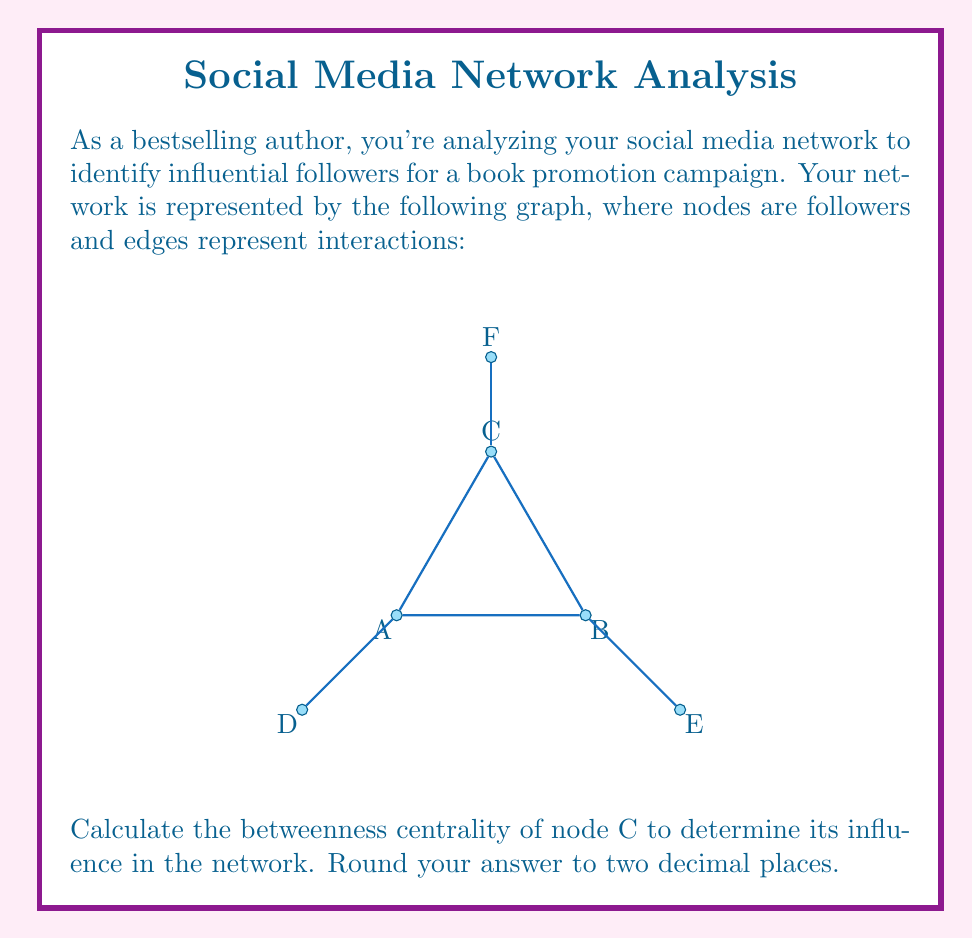What is the answer to this math problem? To calculate the betweenness centrality of node C, we need to follow these steps:

1) First, let's understand what betweenness centrality is. It's a measure of how often a node appears on shortest paths between pairs of other nodes in the network.

2) The formula for betweenness centrality of a node v is:

   $$BC(v) = \sum_{s \neq v \neq t} \frac{\sigma_{st}(v)}{\sigma_{st}}$$

   where $\sigma_{st}$ is the total number of shortest paths from node s to node t, and $\sigma_{st}(v)$ is the number of those paths that pass through v.

3) In this graph, we need to consider all pairs of nodes excluding C, and count how many shortest paths between them pass through C.

4) Let's count:
   - A to B: 1 path, doesn't pass through C
   - A to D: 1 path, doesn't pass through C
   - A to E: 2 paths (A-B-E and A-C-B-E), 1 passes through C
   - A to F: 1 path, passes through C
   - B to D: 2 paths (B-A-D and B-C-A-D), 1 passes through C
   - B to E: 1 path, doesn't pass through C
   - B to F: 1 path, passes through C
   - D to E: 3 paths (D-A-B-E, D-A-C-B-E, D-A-C-E), 2 pass through C
   - D to F: 2 paths (D-A-C-F and D-A-B-C-F), both pass through C
   - E to F: 2 paths (E-B-C-F and E-B-A-C-F), both pass through C

5) Now, let's sum up the fractions:
   $$BC(C) = \frac{1}{2} + 1 + \frac{1}{2} + 1 + \frac{2}{3} + 1 + 1 = 5.6667$$

6) Rounding to two decimal places: 5.67
Answer: 5.67 